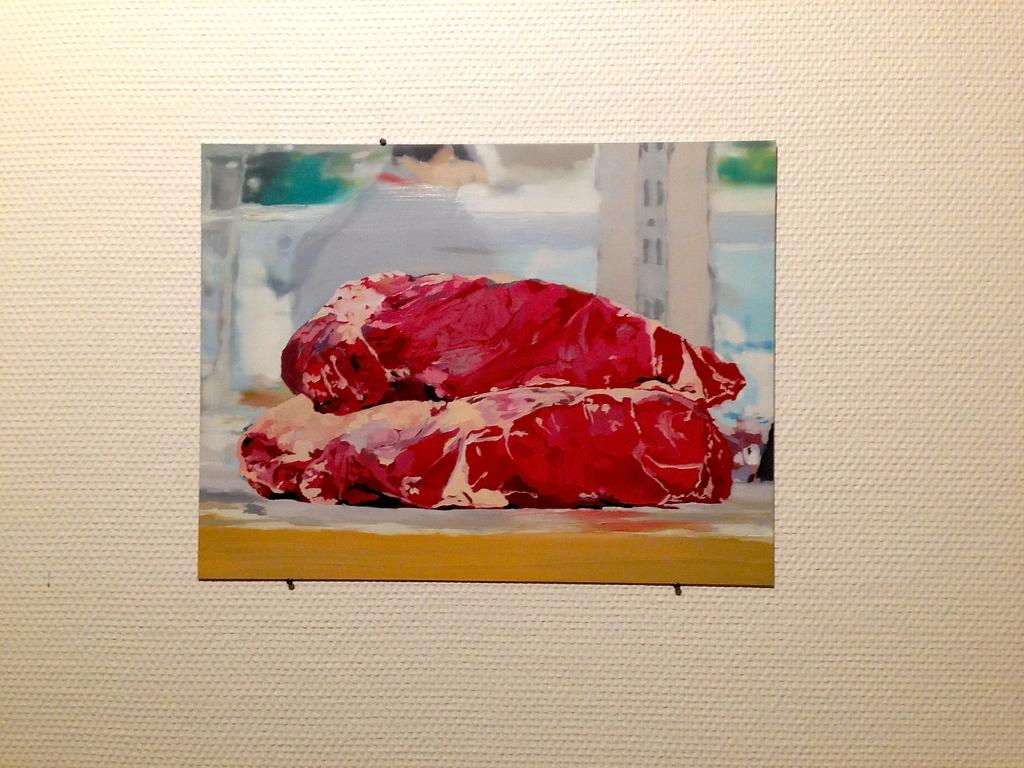What is the color of the main object in the image? The main object in the image is white. What is depicted on the white object? The white object has a painting on it. What color can be seen in the painting? The painting contains red-colored elements. How does the white object provide support in the image? The white object does not provide support in the image; it is a painting on a white object. Is there a lock visible on the white object in the image? There is no lock visible on the white object in the image. 